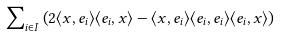Convert formula to latex. <formula><loc_0><loc_0><loc_500><loc_500>\sum \nolimits _ { i \in I } \left ( 2 \langle x , e _ { i } \rangle \langle e _ { i } , x \rangle - \langle x , e _ { i } \rangle \langle e _ { i } , e _ { i } \rangle \langle e _ { i } , x \rangle \right )</formula> 